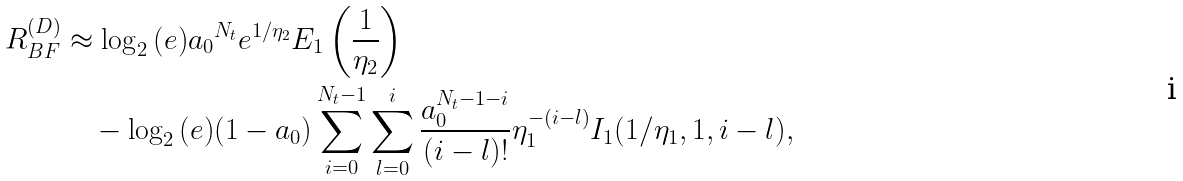Convert formula to latex. <formula><loc_0><loc_0><loc_500><loc_500>R _ { B F } ^ { ( D ) } & \approx \log _ { 2 } { ( e ) } { a _ { 0 } } ^ { N _ { t } } e ^ { 1 / \eta _ { 2 } } E _ { 1 } \left ( \frac { 1 } { \eta _ { 2 } } \right ) \\ & \quad - \log _ { 2 } { ( e ) } ( 1 - a _ { 0 } ) \sum _ { i = 0 } ^ { N _ { t } - 1 } \sum _ { l = 0 } ^ { i } \frac { a _ { 0 } ^ { N _ { t } - 1 - i } } { ( i - l ) ! } \eta _ { 1 } ^ { - ( i - l ) } I _ { 1 } ( 1 / \eta _ { 1 } , 1 , i - l ) ,</formula> 